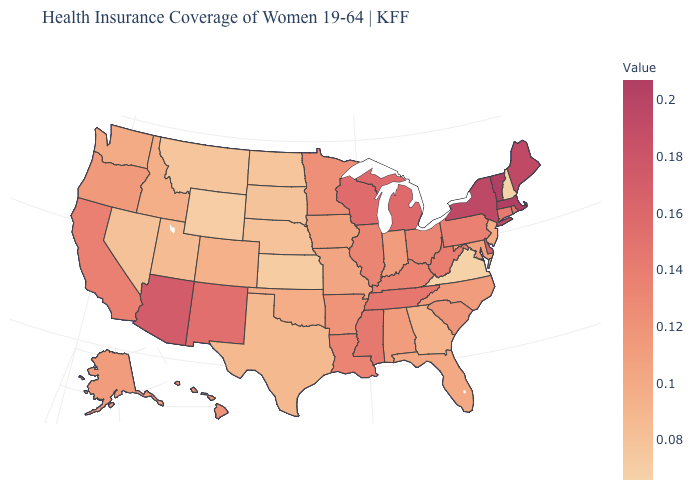Is the legend a continuous bar?
Keep it brief. Yes. Which states hav the highest value in the South?
Give a very brief answer. Delaware. Does the map have missing data?
Keep it brief. No. Does Mississippi have the highest value in the South?
Keep it brief. No. Which states have the highest value in the USA?
Be succinct. Massachusetts, Vermont. 